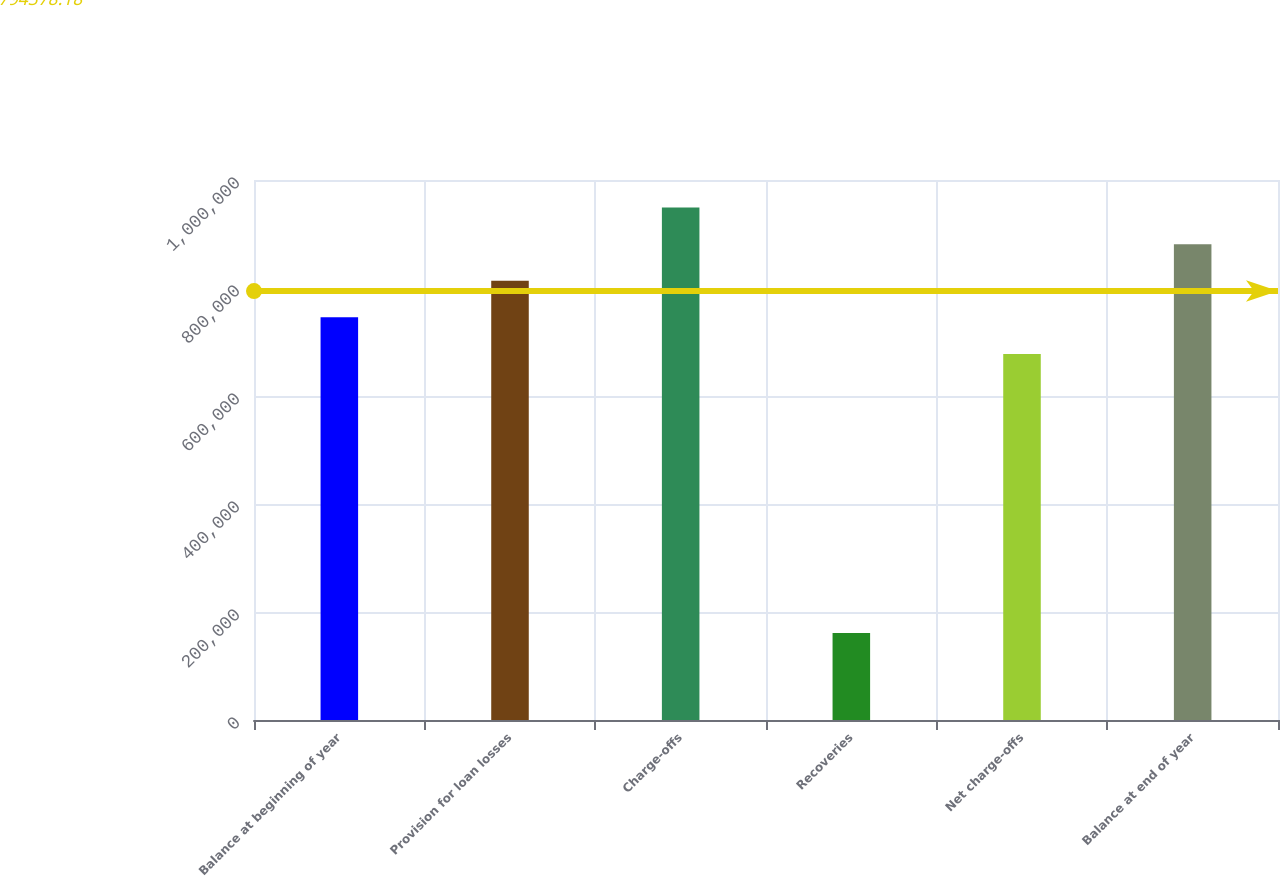Convert chart to OTSL. <chart><loc_0><loc_0><loc_500><loc_500><bar_chart><fcel>Balance at beginning of year<fcel>Provision for loan losses<fcel>Charge-offs<fcel>Recoveries<fcel>Net charge-offs<fcel>Balance at end of year<nl><fcel>745667<fcel>813455<fcel>949031<fcel>161213<fcel>677879<fcel>881243<nl></chart> 